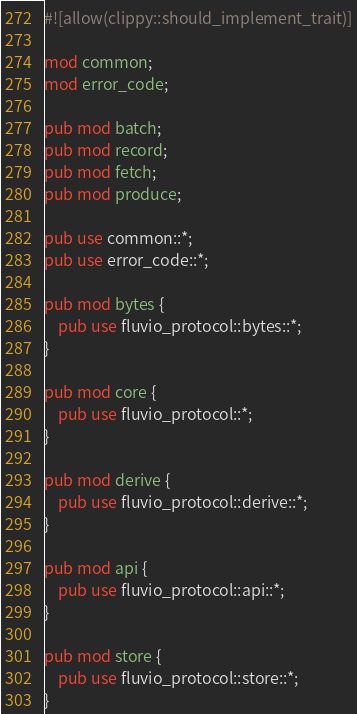Convert code to text. <code><loc_0><loc_0><loc_500><loc_500><_Rust_>#![allow(clippy::should_implement_trait)]

mod common;
mod error_code;

pub mod batch;
pub mod record;
pub mod fetch;
pub mod produce;

pub use common::*;
pub use error_code::*;

pub mod bytes {
    pub use fluvio_protocol::bytes::*;
}

pub mod core {
    pub use fluvio_protocol::*;
}

pub mod derive {
    pub use fluvio_protocol::derive::*;
}

pub mod api {
    pub use fluvio_protocol::api::*;
}

pub mod store {
    pub use fluvio_protocol::store::*;
}
</code> 